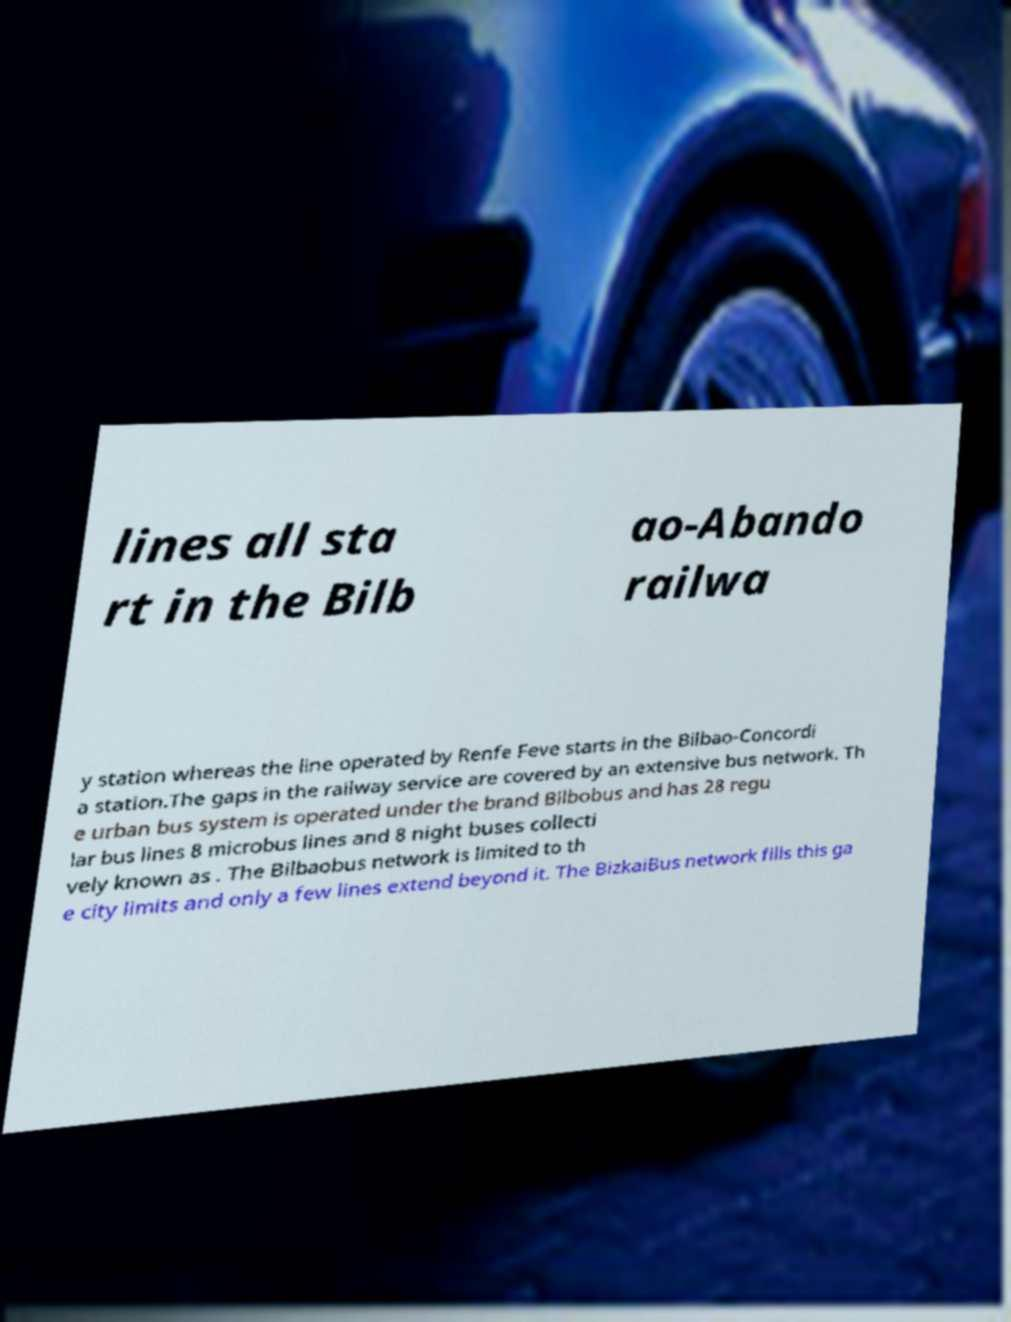Please read and relay the text visible in this image. What does it say? lines all sta rt in the Bilb ao-Abando railwa y station whereas the line operated by Renfe Feve starts in the Bilbao-Concordi a station.The gaps in the railway service are covered by an extensive bus network. Th e urban bus system is operated under the brand Bilbobus and has 28 regu lar bus lines 8 microbus lines and 8 night buses collecti vely known as . The Bilbaobus network is limited to th e city limits and only a few lines extend beyond it. The BizkaiBus network fills this ga 